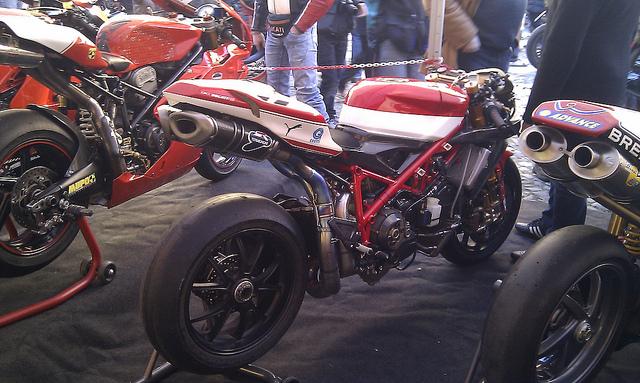Is this a parking lot for motorbikes?
Answer briefly. Yes. How many bikes are visible?
Concise answer only. 3. What color is the ground?
Quick response, please. Black. 